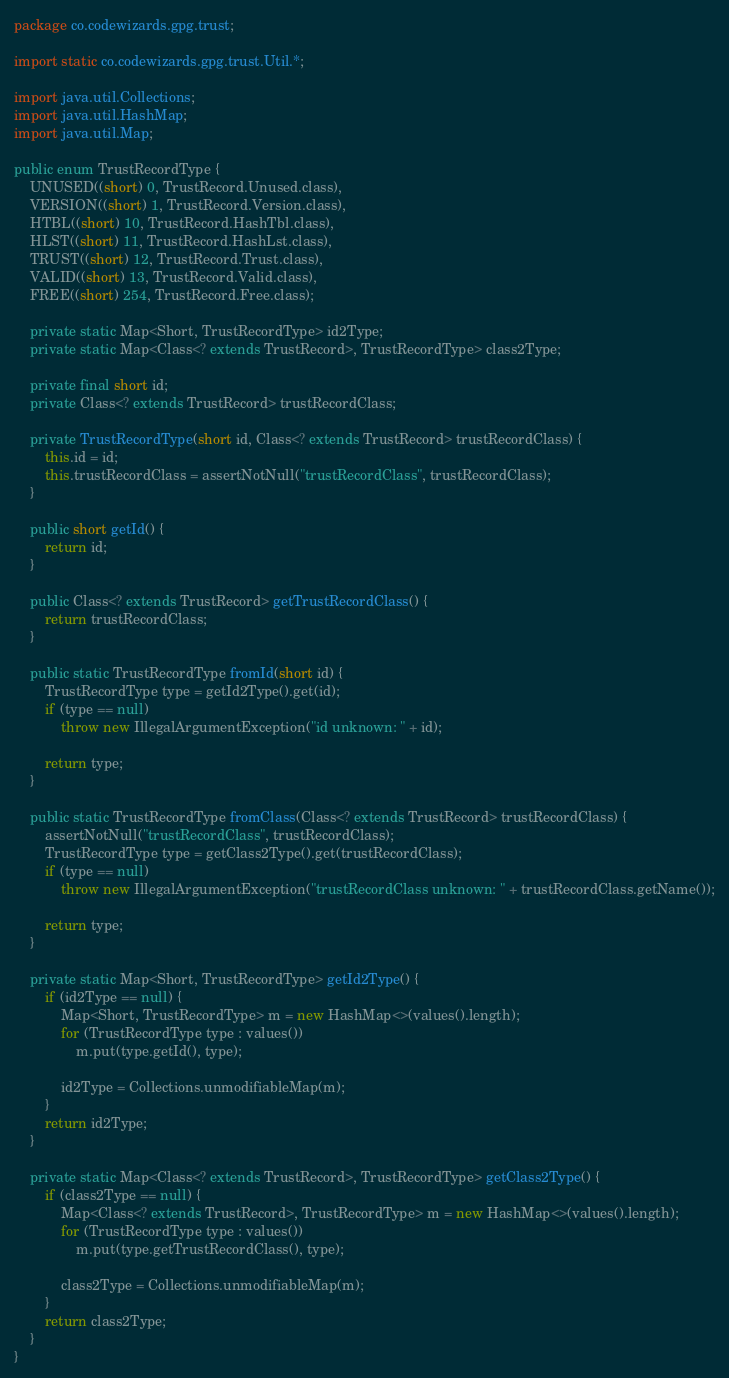Convert code to text. <code><loc_0><loc_0><loc_500><loc_500><_Java_>package co.codewizards.gpg.trust;

import static co.codewizards.gpg.trust.Util.*;

import java.util.Collections;
import java.util.HashMap;
import java.util.Map;

public enum TrustRecordType {
	UNUSED((short) 0, TrustRecord.Unused.class),
	VERSION((short) 1, TrustRecord.Version.class),
	HTBL((short) 10, TrustRecord.HashTbl.class),
	HLST((short) 11, TrustRecord.HashLst.class),
	TRUST((short) 12, TrustRecord.Trust.class),
	VALID((short) 13, TrustRecord.Valid.class),
	FREE((short) 254, TrustRecord.Free.class);

	private static Map<Short, TrustRecordType> id2Type;
	private static Map<Class<? extends TrustRecord>, TrustRecordType> class2Type;

	private final short id;
	private Class<? extends TrustRecord> trustRecordClass;

	private TrustRecordType(short id, Class<? extends TrustRecord> trustRecordClass) {
		this.id = id;
		this.trustRecordClass = assertNotNull("trustRecordClass", trustRecordClass);
	}

	public short getId() {
		return id;
	}

	public Class<? extends TrustRecord> getTrustRecordClass() {
		return trustRecordClass;
	}

	public static TrustRecordType fromId(short id) {
		TrustRecordType type = getId2Type().get(id);
		if (type == null)
			throw new IllegalArgumentException("id unknown: " + id);

		return type;
	}

	public static TrustRecordType fromClass(Class<? extends TrustRecord> trustRecordClass) {
		assertNotNull("trustRecordClass", trustRecordClass);
		TrustRecordType type = getClass2Type().get(trustRecordClass);
		if (type == null)
			throw new IllegalArgumentException("trustRecordClass unknown: " + trustRecordClass.getName());

		return type;
	}

	private static Map<Short, TrustRecordType> getId2Type() {
		if (id2Type == null) {
			Map<Short, TrustRecordType> m = new HashMap<>(values().length);
			for (TrustRecordType type : values())
				m.put(type.getId(), type);

			id2Type = Collections.unmodifiableMap(m);
		}
		return id2Type;
	}

	private static Map<Class<? extends TrustRecord>, TrustRecordType> getClass2Type() {
		if (class2Type == null) {
			Map<Class<? extends TrustRecord>, TrustRecordType> m = new HashMap<>(values().length);
			for (TrustRecordType type : values())
				m.put(type.getTrustRecordClass(), type);

			class2Type = Collections.unmodifiableMap(m);
		}
		return class2Type;
	}
}
</code> 